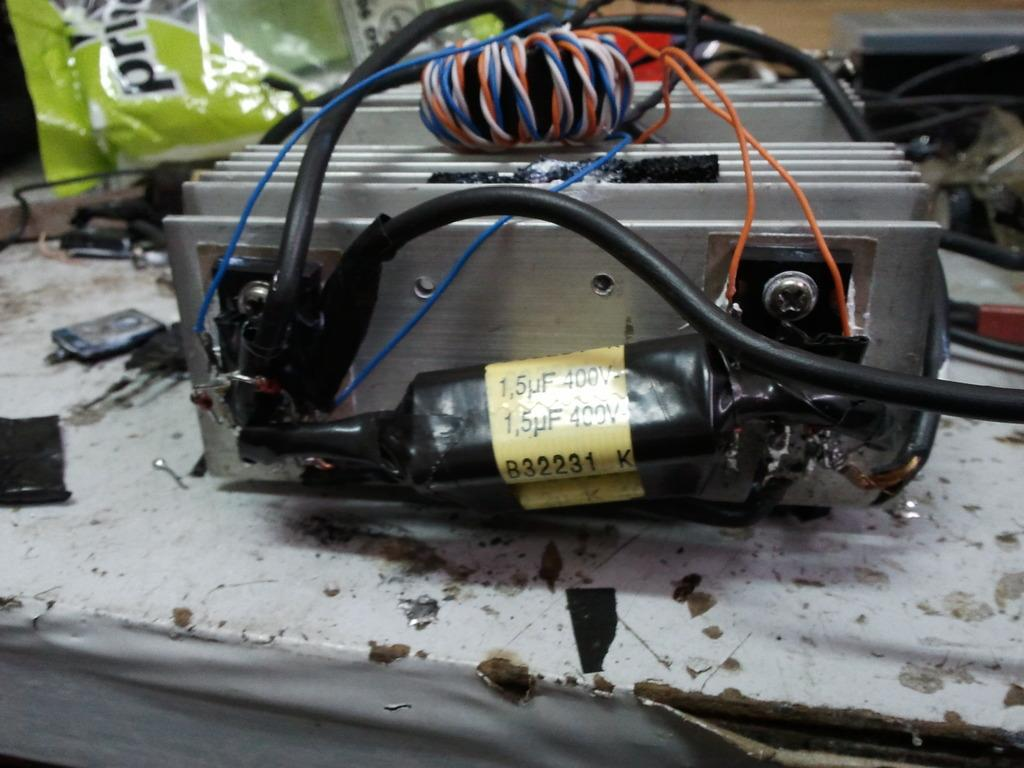What is the main subject in the foreground of the image? There is an electronic device in the foreground of the image. What is connected to the electronic device? Cables are attached to the electronic device. What color is the cover visible in the background of the image? There is a green colored cover in the background of the image. What else can be seen in the background of the image? There are objects visible in the background of the image. How does the son interact with the electronic device during the rainstorm in the image? There is no son or rainstorm present in the image; it only features an electronic device with cables and a green colored cover in the background. 